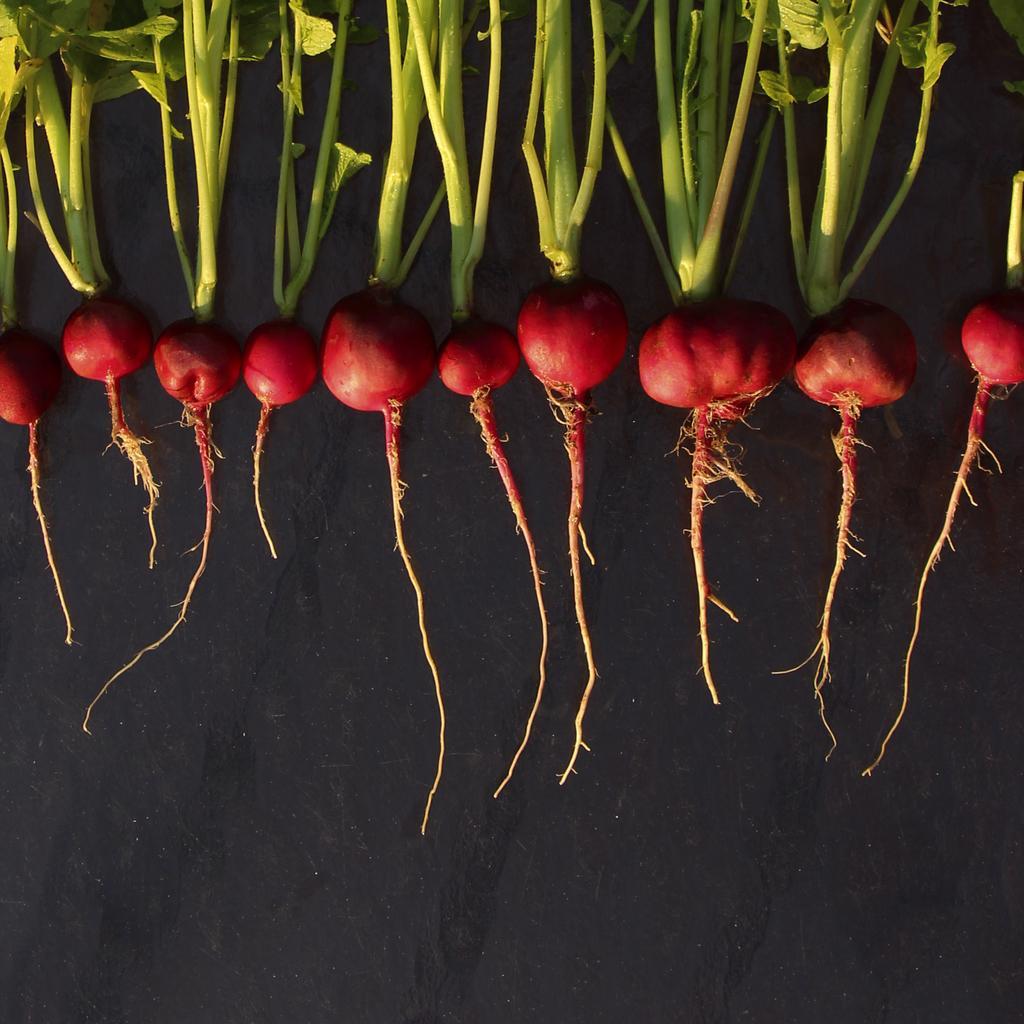Please provide a concise description of this image. In this image, we can see few beetroots with stems, leaves and roots on the black surface. 